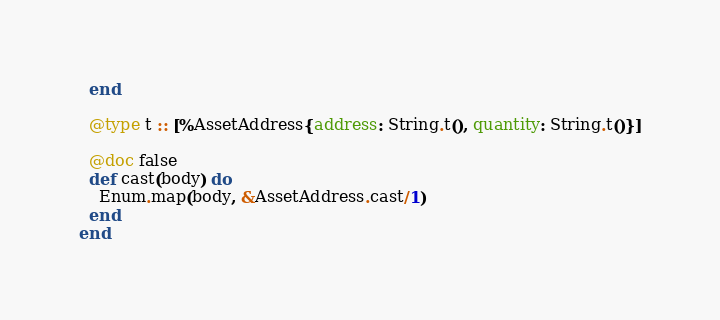Convert code to text. <code><loc_0><loc_0><loc_500><loc_500><_Elixir_>  end

  @type t :: [%AssetAddress{address: String.t(), quantity: String.t()}]

  @doc false
  def cast(body) do
    Enum.map(body, &AssetAddress.cast/1)
  end
end
</code> 